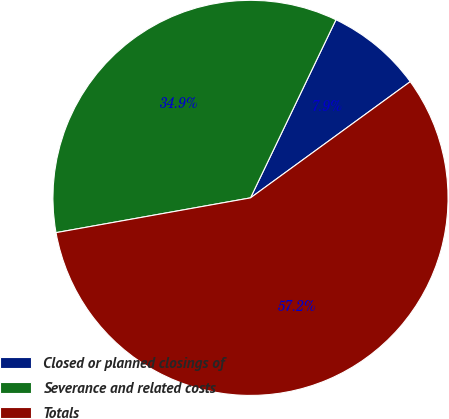Convert chart. <chart><loc_0><loc_0><loc_500><loc_500><pie_chart><fcel>Closed or planned closings of<fcel>Severance and related costs<fcel>Totals<nl><fcel>7.87%<fcel>34.94%<fcel>57.2%<nl></chart> 